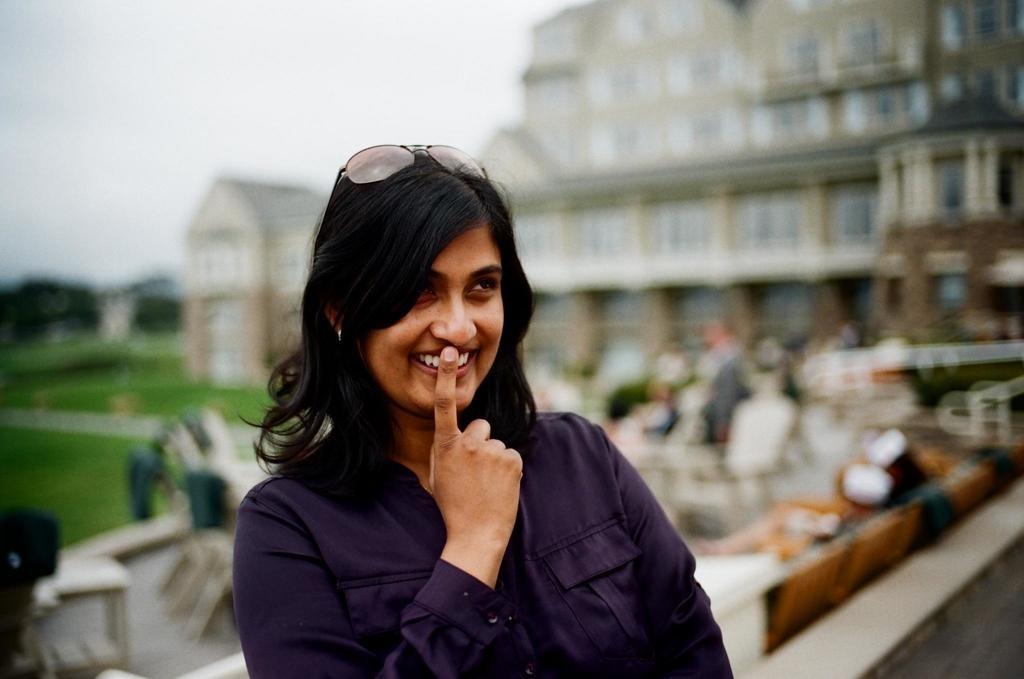Who is the main subject in the image? There is a lady in the center of the image. What can be observed about the background of the image? The background of the image is blurred. What type of pump can be seen in the image? There is no pump present in the image. What type of bed is visible in the image? There is no bed present in the image. 